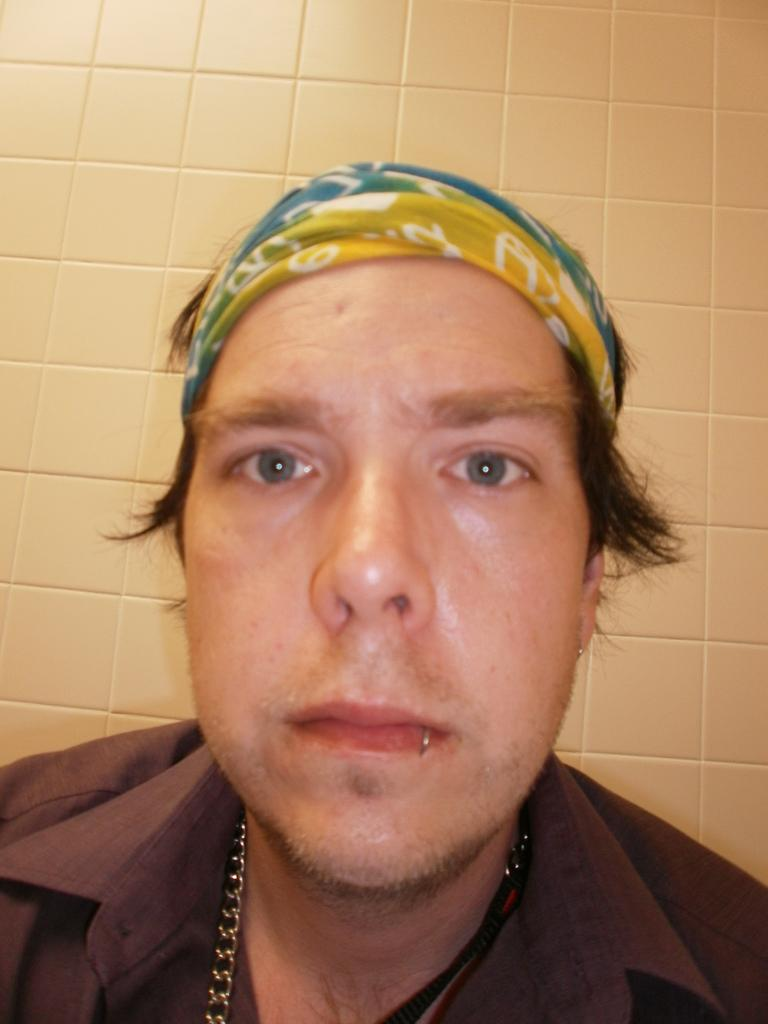What is present in the image? There is a person in the image. What is the person wearing? The person is wearing a brown shirt. What can be seen on the wall in the background of the image? There are tiles on the wall in the background of the image. What type of fruit is the person holding in the image? There is no fruit present in the image; the person is not holding any fruit. Did the person receive approval for their haircut in the image? There is no indication of a haircut or approval in the image. 